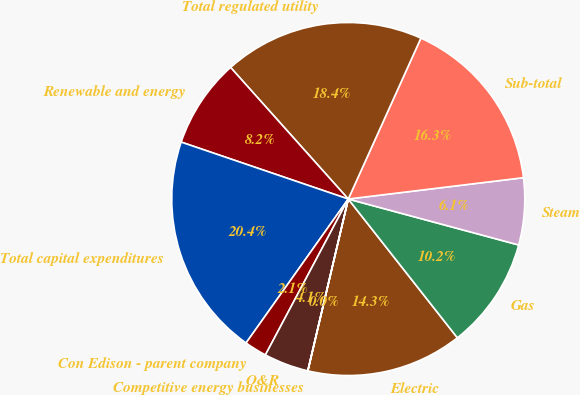Convert chart. <chart><loc_0><loc_0><loc_500><loc_500><pie_chart><fcel>Electric<fcel>Gas<fcel>Steam<fcel>Sub-total<fcel>Total regulated utility<fcel>Renewable and energy<fcel>Total capital expenditures<fcel>Con Edison - parent company<fcel>O&R<fcel>Competitive energy businesses<nl><fcel>14.28%<fcel>10.2%<fcel>6.12%<fcel>16.32%<fcel>18.36%<fcel>8.16%<fcel>20.4%<fcel>2.05%<fcel>4.09%<fcel>0.01%<nl></chart> 